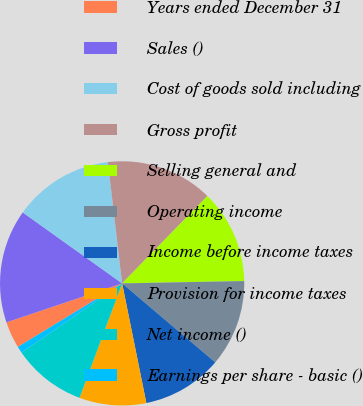Convert chart. <chart><loc_0><loc_0><loc_500><loc_500><pie_chart><fcel>Years ended December 31<fcel>Sales ()<fcel>Cost of goods sold including<fcel>Gross profit<fcel>Selling general and<fcel>Operating income<fcel>Income before income taxes<fcel>Provision for income taxes<fcel>Net income ()<fcel>Earnings per share - basic ()<nl><fcel>3.54%<fcel>15.04%<fcel>13.27%<fcel>14.16%<fcel>12.39%<fcel>11.5%<fcel>10.62%<fcel>8.85%<fcel>9.73%<fcel>0.88%<nl></chart> 